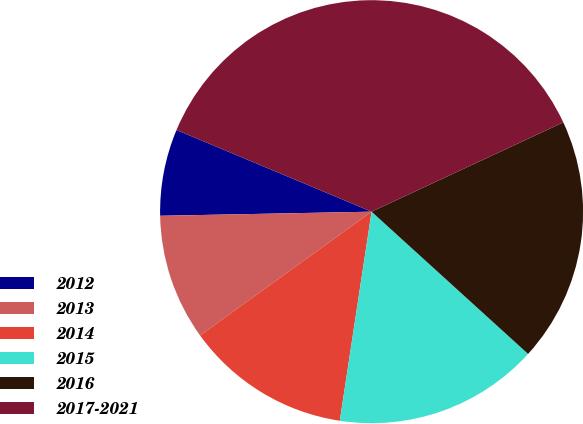<chart> <loc_0><loc_0><loc_500><loc_500><pie_chart><fcel>2012<fcel>2013<fcel>2014<fcel>2015<fcel>2016<fcel>2017-2021<nl><fcel>6.62%<fcel>9.64%<fcel>12.65%<fcel>15.66%<fcel>18.68%<fcel>36.75%<nl></chart> 